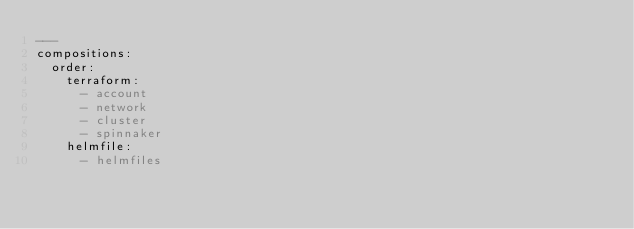<code> <loc_0><loc_0><loc_500><loc_500><_YAML_>---
compositions:
  order:
    terraform:
      - account
      - network
      - cluster
      - spinnaker
    helmfile:
      - helmfiles
</code> 